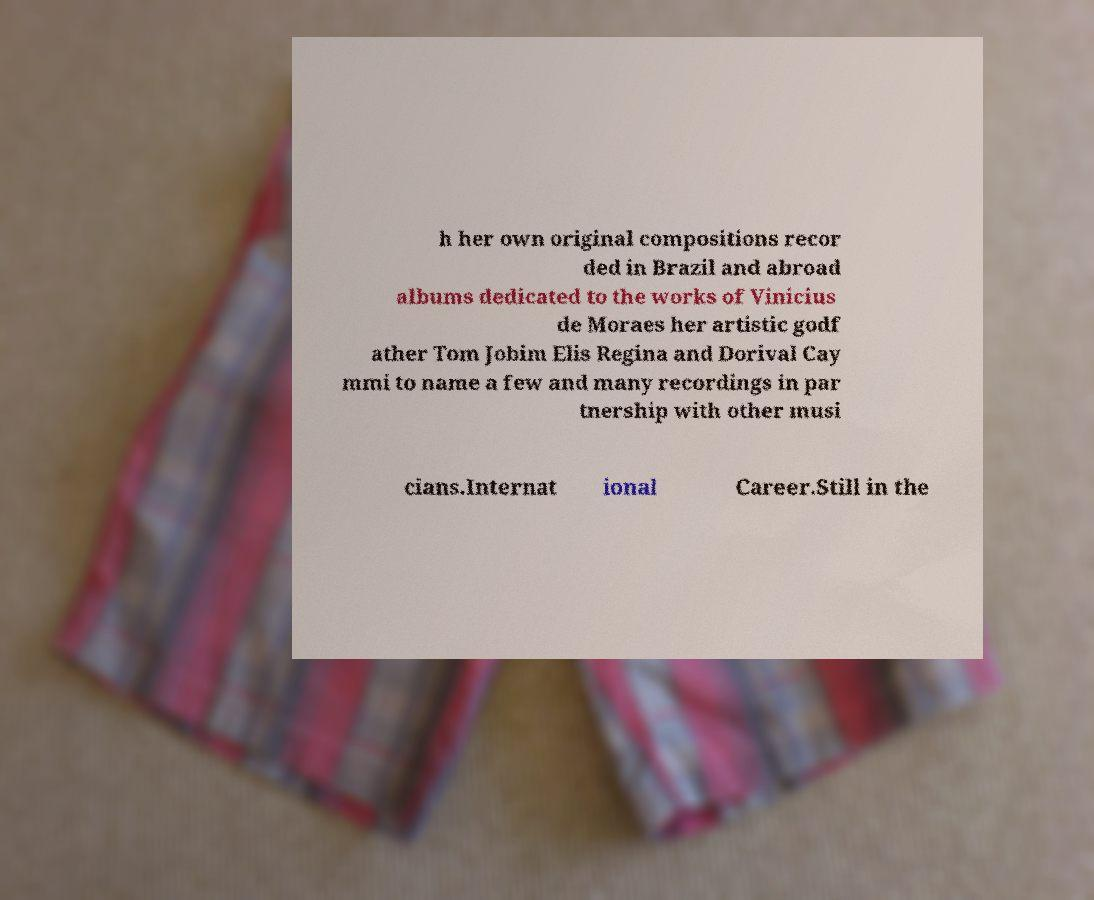There's text embedded in this image that I need extracted. Can you transcribe it verbatim? h her own original compositions recor ded in Brazil and abroad albums dedicated to the works of Vinicius de Moraes her artistic godf ather Tom Jobim Elis Regina and Dorival Cay mmi to name a few and many recordings in par tnership with other musi cians.Internat ional Career.Still in the 